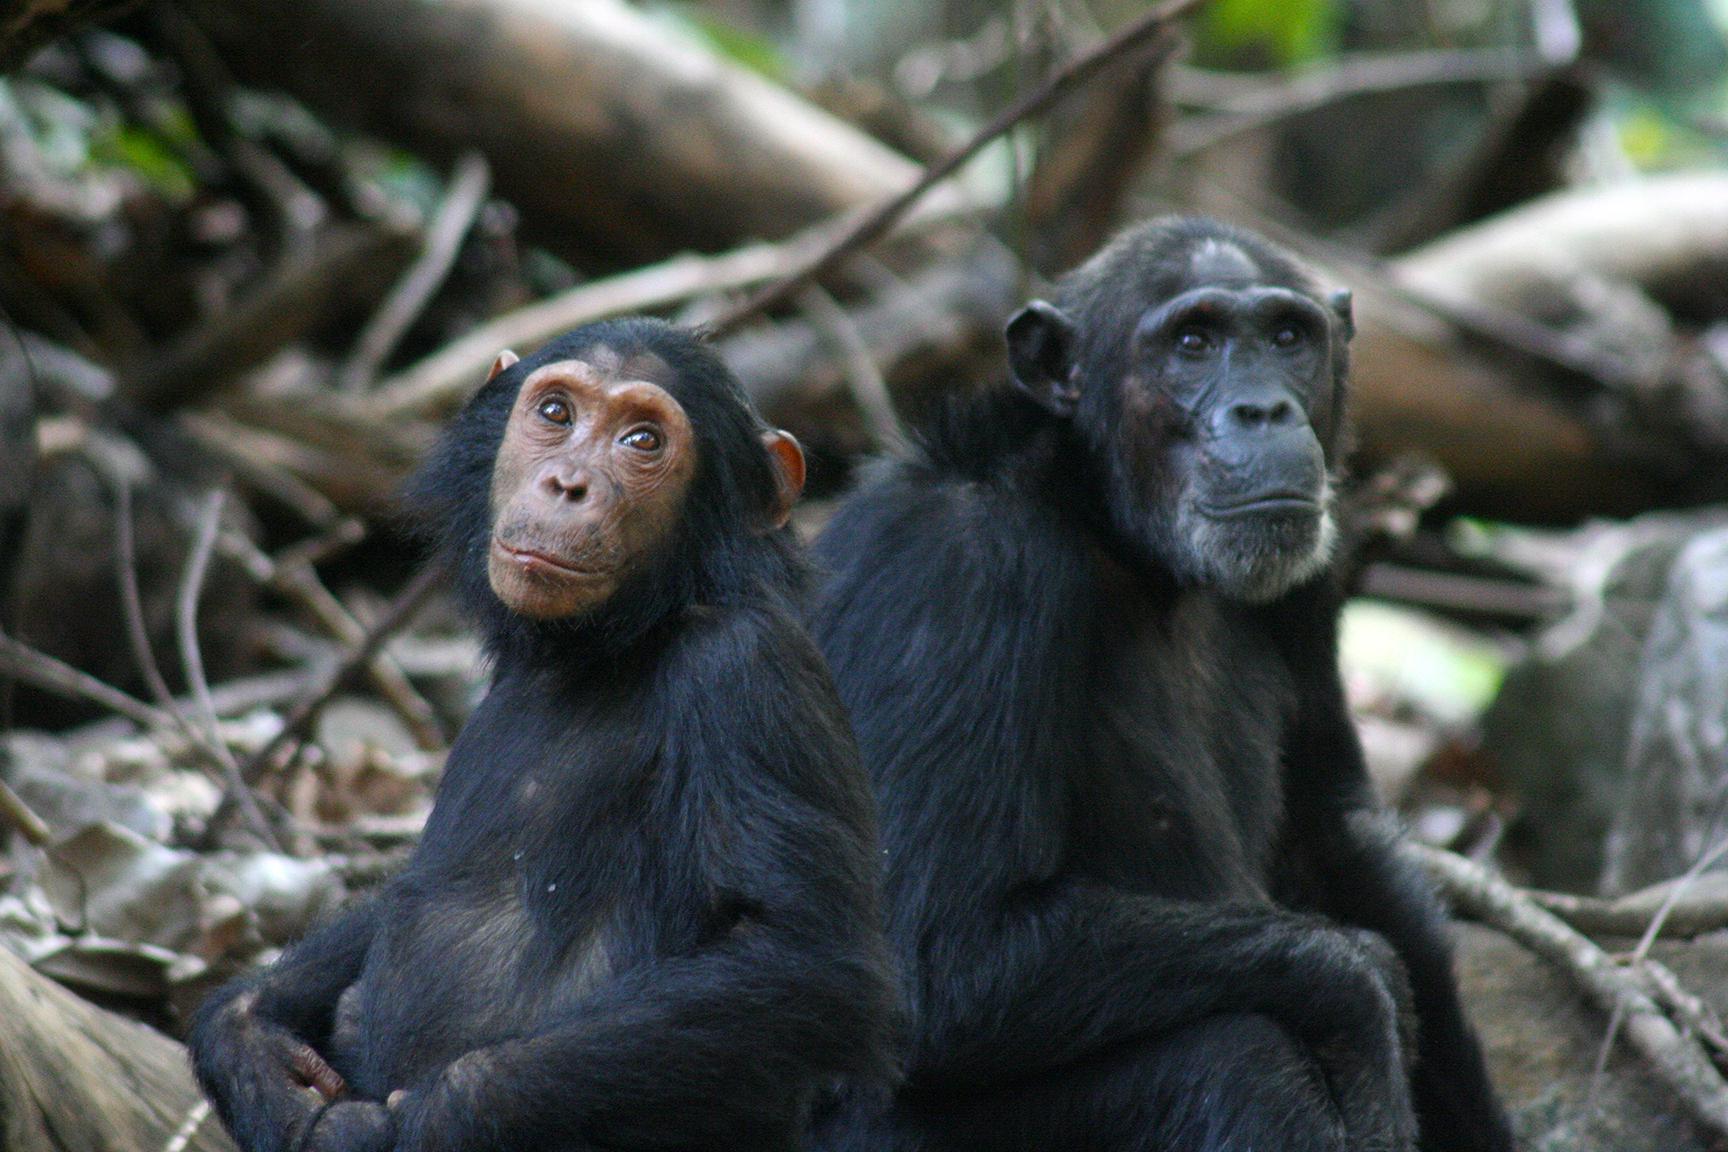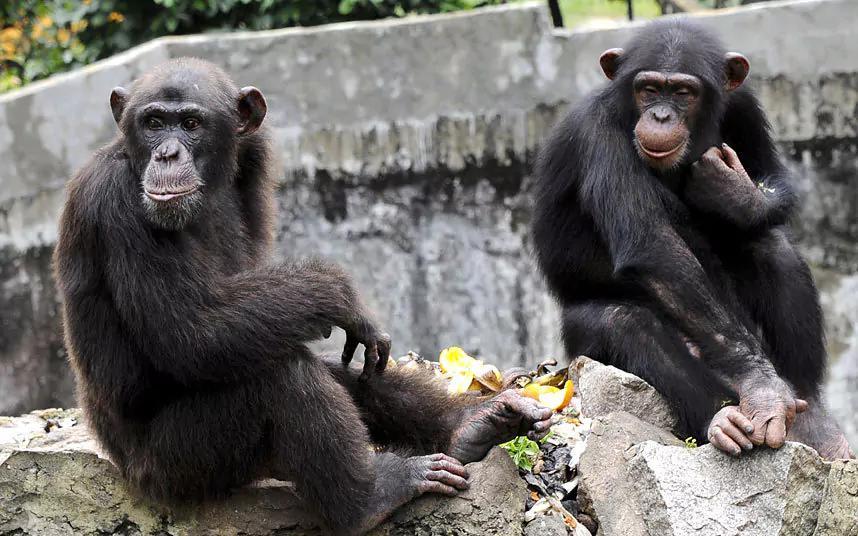The first image is the image on the left, the second image is the image on the right. Analyze the images presented: Is the assertion "There are four monkeys." valid? Answer yes or no. Yes. The first image is the image on the left, the second image is the image on the right. For the images displayed, is the sentence "Each image contains a pair of chimps posed near each other, and no chimps are young babies." factually correct? Answer yes or no. Yes. 